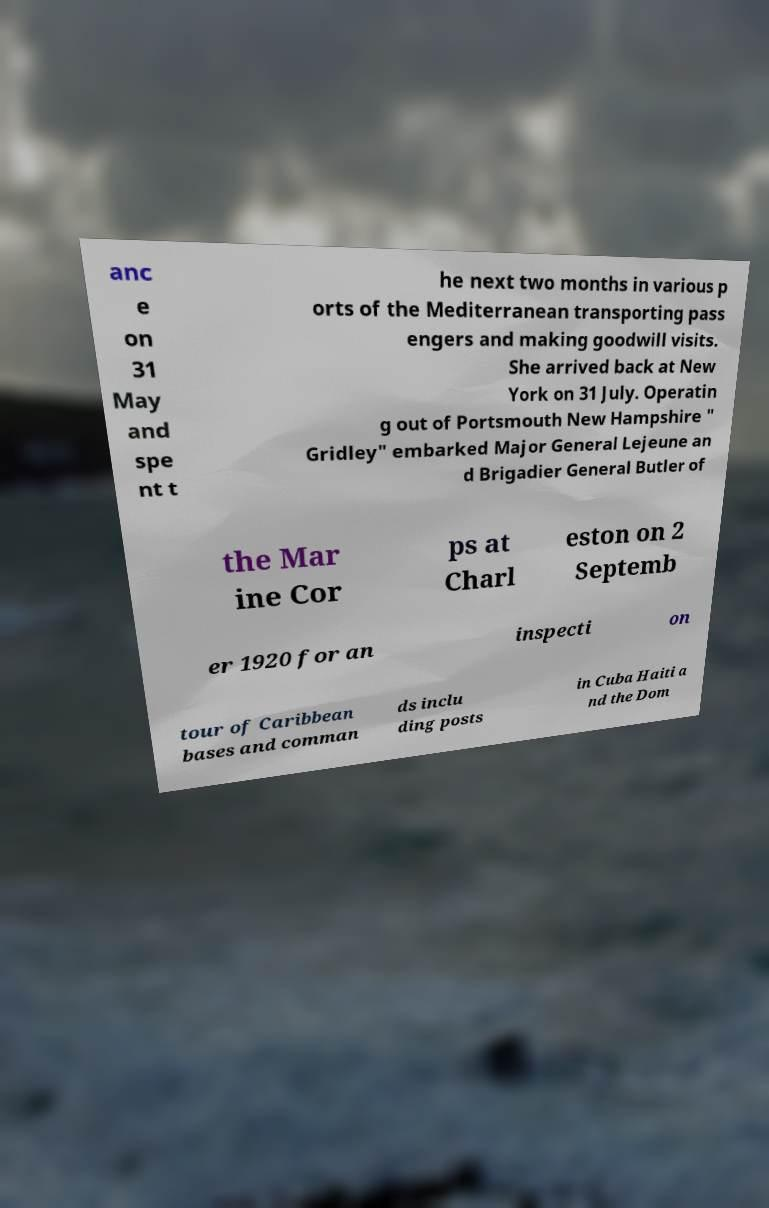Can you read and provide the text displayed in the image?This photo seems to have some interesting text. Can you extract and type it out for me? anc e on 31 May and spe nt t he next two months in various p orts of the Mediterranean transporting pass engers and making goodwill visits. She arrived back at New York on 31 July. Operatin g out of Portsmouth New Hampshire " Gridley" embarked Major General Lejeune an d Brigadier General Butler of the Mar ine Cor ps at Charl eston on 2 Septemb er 1920 for an inspecti on tour of Caribbean bases and comman ds inclu ding posts in Cuba Haiti a nd the Dom 